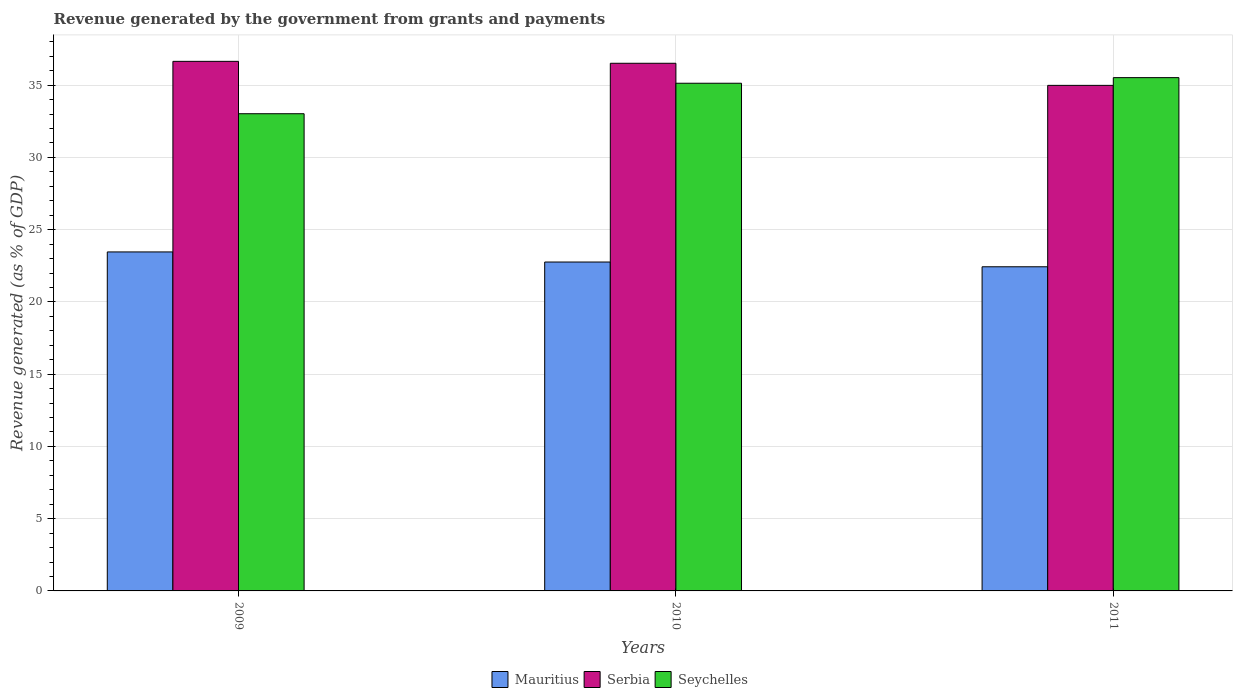How many groups of bars are there?
Your answer should be compact. 3. How many bars are there on the 2nd tick from the left?
Offer a very short reply. 3. What is the revenue generated by the government in Seychelles in 2010?
Your answer should be very brief. 35.13. Across all years, what is the maximum revenue generated by the government in Mauritius?
Your answer should be compact. 23.46. Across all years, what is the minimum revenue generated by the government in Serbia?
Offer a very short reply. 34.99. In which year was the revenue generated by the government in Seychelles maximum?
Give a very brief answer. 2011. In which year was the revenue generated by the government in Mauritius minimum?
Offer a terse response. 2011. What is the total revenue generated by the government in Seychelles in the graph?
Your answer should be compact. 103.68. What is the difference between the revenue generated by the government in Seychelles in 2010 and that in 2011?
Give a very brief answer. -0.39. What is the difference between the revenue generated by the government in Serbia in 2010 and the revenue generated by the government in Mauritius in 2009?
Provide a short and direct response. 13.06. What is the average revenue generated by the government in Mauritius per year?
Your response must be concise. 22.89. In the year 2011, what is the difference between the revenue generated by the government in Seychelles and revenue generated by the government in Mauritius?
Your response must be concise. 13.09. In how many years, is the revenue generated by the government in Serbia greater than 24 %?
Provide a short and direct response. 3. What is the ratio of the revenue generated by the government in Seychelles in 2009 to that in 2011?
Your response must be concise. 0.93. What is the difference between the highest and the second highest revenue generated by the government in Serbia?
Ensure brevity in your answer.  0.13. What is the difference between the highest and the lowest revenue generated by the government in Mauritius?
Your answer should be compact. 1.03. What does the 2nd bar from the left in 2011 represents?
Your response must be concise. Serbia. What does the 2nd bar from the right in 2010 represents?
Provide a short and direct response. Serbia. How many bars are there?
Make the answer very short. 9. How many years are there in the graph?
Your response must be concise. 3. Does the graph contain grids?
Ensure brevity in your answer.  Yes. Where does the legend appear in the graph?
Offer a terse response. Bottom center. How many legend labels are there?
Provide a succinct answer. 3. What is the title of the graph?
Provide a short and direct response. Revenue generated by the government from grants and payments. Does "Saudi Arabia" appear as one of the legend labels in the graph?
Make the answer very short. No. What is the label or title of the X-axis?
Ensure brevity in your answer.  Years. What is the label or title of the Y-axis?
Provide a succinct answer. Revenue generated (as % of GDP). What is the Revenue generated (as % of GDP) of Mauritius in 2009?
Your answer should be very brief. 23.46. What is the Revenue generated (as % of GDP) of Serbia in 2009?
Offer a very short reply. 36.65. What is the Revenue generated (as % of GDP) in Seychelles in 2009?
Offer a terse response. 33.03. What is the Revenue generated (as % of GDP) of Mauritius in 2010?
Your answer should be very brief. 22.76. What is the Revenue generated (as % of GDP) of Serbia in 2010?
Your answer should be compact. 36.52. What is the Revenue generated (as % of GDP) in Seychelles in 2010?
Offer a very short reply. 35.13. What is the Revenue generated (as % of GDP) of Mauritius in 2011?
Your answer should be very brief. 22.43. What is the Revenue generated (as % of GDP) in Serbia in 2011?
Make the answer very short. 34.99. What is the Revenue generated (as % of GDP) in Seychelles in 2011?
Offer a very short reply. 35.52. Across all years, what is the maximum Revenue generated (as % of GDP) in Mauritius?
Offer a very short reply. 23.46. Across all years, what is the maximum Revenue generated (as % of GDP) of Serbia?
Your answer should be very brief. 36.65. Across all years, what is the maximum Revenue generated (as % of GDP) in Seychelles?
Keep it short and to the point. 35.52. Across all years, what is the minimum Revenue generated (as % of GDP) in Mauritius?
Your response must be concise. 22.43. Across all years, what is the minimum Revenue generated (as % of GDP) in Serbia?
Provide a short and direct response. 34.99. Across all years, what is the minimum Revenue generated (as % of GDP) of Seychelles?
Ensure brevity in your answer.  33.03. What is the total Revenue generated (as % of GDP) in Mauritius in the graph?
Make the answer very short. 68.66. What is the total Revenue generated (as % of GDP) of Serbia in the graph?
Ensure brevity in your answer.  108.16. What is the total Revenue generated (as % of GDP) of Seychelles in the graph?
Offer a terse response. 103.68. What is the difference between the Revenue generated (as % of GDP) in Mauritius in 2009 and that in 2010?
Offer a terse response. 0.7. What is the difference between the Revenue generated (as % of GDP) of Serbia in 2009 and that in 2010?
Your response must be concise. 0.13. What is the difference between the Revenue generated (as % of GDP) in Seychelles in 2009 and that in 2010?
Give a very brief answer. -2.11. What is the difference between the Revenue generated (as % of GDP) in Mauritius in 2009 and that in 2011?
Your response must be concise. 1.03. What is the difference between the Revenue generated (as % of GDP) of Serbia in 2009 and that in 2011?
Your response must be concise. 1.66. What is the difference between the Revenue generated (as % of GDP) of Seychelles in 2009 and that in 2011?
Keep it short and to the point. -2.5. What is the difference between the Revenue generated (as % of GDP) of Mauritius in 2010 and that in 2011?
Give a very brief answer. 0.33. What is the difference between the Revenue generated (as % of GDP) of Serbia in 2010 and that in 2011?
Give a very brief answer. 1.53. What is the difference between the Revenue generated (as % of GDP) in Seychelles in 2010 and that in 2011?
Your answer should be compact. -0.39. What is the difference between the Revenue generated (as % of GDP) in Mauritius in 2009 and the Revenue generated (as % of GDP) in Serbia in 2010?
Offer a very short reply. -13.06. What is the difference between the Revenue generated (as % of GDP) of Mauritius in 2009 and the Revenue generated (as % of GDP) of Seychelles in 2010?
Provide a succinct answer. -11.67. What is the difference between the Revenue generated (as % of GDP) of Serbia in 2009 and the Revenue generated (as % of GDP) of Seychelles in 2010?
Give a very brief answer. 1.52. What is the difference between the Revenue generated (as % of GDP) of Mauritius in 2009 and the Revenue generated (as % of GDP) of Serbia in 2011?
Give a very brief answer. -11.53. What is the difference between the Revenue generated (as % of GDP) of Mauritius in 2009 and the Revenue generated (as % of GDP) of Seychelles in 2011?
Keep it short and to the point. -12.06. What is the difference between the Revenue generated (as % of GDP) in Serbia in 2009 and the Revenue generated (as % of GDP) in Seychelles in 2011?
Offer a very short reply. 1.13. What is the difference between the Revenue generated (as % of GDP) in Mauritius in 2010 and the Revenue generated (as % of GDP) in Serbia in 2011?
Give a very brief answer. -12.23. What is the difference between the Revenue generated (as % of GDP) of Mauritius in 2010 and the Revenue generated (as % of GDP) of Seychelles in 2011?
Keep it short and to the point. -12.76. What is the difference between the Revenue generated (as % of GDP) of Serbia in 2010 and the Revenue generated (as % of GDP) of Seychelles in 2011?
Keep it short and to the point. 0.99. What is the average Revenue generated (as % of GDP) in Mauritius per year?
Your response must be concise. 22.89. What is the average Revenue generated (as % of GDP) of Serbia per year?
Give a very brief answer. 36.05. What is the average Revenue generated (as % of GDP) of Seychelles per year?
Your answer should be compact. 34.56. In the year 2009, what is the difference between the Revenue generated (as % of GDP) in Mauritius and Revenue generated (as % of GDP) in Serbia?
Provide a short and direct response. -13.19. In the year 2009, what is the difference between the Revenue generated (as % of GDP) of Mauritius and Revenue generated (as % of GDP) of Seychelles?
Your response must be concise. -9.57. In the year 2009, what is the difference between the Revenue generated (as % of GDP) in Serbia and Revenue generated (as % of GDP) in Seychelles?
Ensure brevity in your answer.  3.62. In the year 2010, what is the difference between the Revenue generated (as % of GDP) in Mauritius and Revenue generated (as % of GDP) in Serbia?
Keep it short and to the point. -13.76. In the year 2010, what is the difference between the Revenue generated (as % of GDP) of Mauritius and Revenue generated (as % of GDP) of Seychelles?
Offer a terse response. -12.37. In the year 2010, what is the difference between the Revenue generated (as % of GDP) in Serbia and Revenue generated (as % of GDP) in Seychelles?
Your answer should be compact. 1.38. In the year 2011, what is the difference between the Revenue generated (as % of GDP) in Mauritius and Revenue generated (as % of GDP) in Serbia?
Provide a succinct answer. -12.55. In the year 2011, what is the difference between the Revenue generated (as % of GDP) in Mauritius and Revenue generated (as % of GDP) in Seychelles?
Give a very brief answer. -13.09. In the year 2011, what is the difference between the Revenue generated (as % of GDP) of Serbia and Revenue generated (as % of GDP) of Seychelles?
Keep it short and to the point. -0.53. What is the ratio of the Revenue generated (as % of GDP) in Mauritius in 2009 to that in 2010?
Ensure brevity in your answer.  1.03. What is the ratio of the Revenue generated (as % of GDP) in Seychelles in 2009 to that in 2010?
Your answer should be very brief. 0.94. What is the ratio of the Revenue generated (as % of GDP) of Mauritius in 2009 to that in 2011?
Your answer should be very brief. 1.05. What is the ratio of the Revenue generated (as % of GDP) of Serbia in 2009 to that in 2011?
Ensure brevity in your answer.  1.05. What is the ratio of the Revenue generated (as % of GDP) of Seychelles in 2009 to that in 2011?
Your answer should be very brief. 0.93. What is the ratio of the Revenue generated (as % of GDP) of Mauritius in 2010 to that in 2011?
Your answer should be compact. 1.01. What is the ratio of the Revenue generated (as % of GDP) in Serbia in 2010 to that in 2011?
Keep it short and to the point. 1.04. What is the difference between the highest and the second highest Revenue generated (as % of GDP) in Mauritius?
Provide a succinct answer. 0.7. What is the difference between the highest and the second highest Revenue generated (as % of GDP) in Serbia?
Offer a terse response. 0.13. What is the difference between the highest and the second highest Revenue generated (as % of GDP) of Seychelles?
Provide a short and direct response. 0.39. What is the difference between the highest and the lowest Revenue generated (as % of GDP) in Mauritius?
Your answer should be very brief. 1.03. What is the difference between the highest and the lowest Revenue generated (as % of GDP) of Serbia?
Ensure brevity in your answer.  1.66. What is the difference between the highest and the lowest Revenue generated (as % of GDP) in Seychelles?
Your answer should be compact. 2.5. 